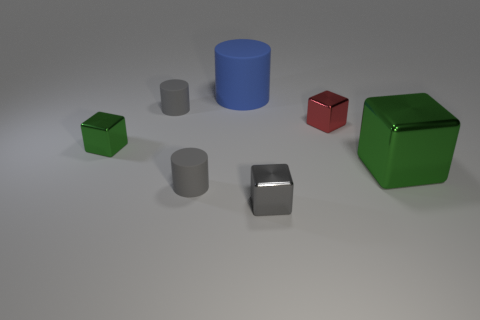Subtract all small red cubes. How many cubes are left? 3 Subtract all gray cylinders. How many cylinders are left? 1 Subtract 3 blocks. How many blocks are left? 1 Add 1 blue matte objects. How many objects exist? 8 Subtract all cyan blocks. Subtract all red cylinders. How many blocks are left? 4 Subtract 0 brown spheres. How many objects are left? 7 Subtract all blocks. How many objects are left? 3 Subtract all red cylinders. How many purple blocks are left? 0 Subtract all blue things. Subtract all gray rubber things. How many objects are left? 4 Add 5 red shiny blocks. How many red shiny blocks are left? 6 